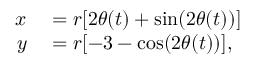<formula> <loc_0><loc_0><loc_500><loc_500>\begin{array} { r l } { x } & = r [ 2 \theta ( t ) + \sin ( 2 \theta ( t ) ) ] } \\ { y } & = r [ - 3 - \cos ( 2 \theta ( t ) ) ] , } \end{array}</formula> 